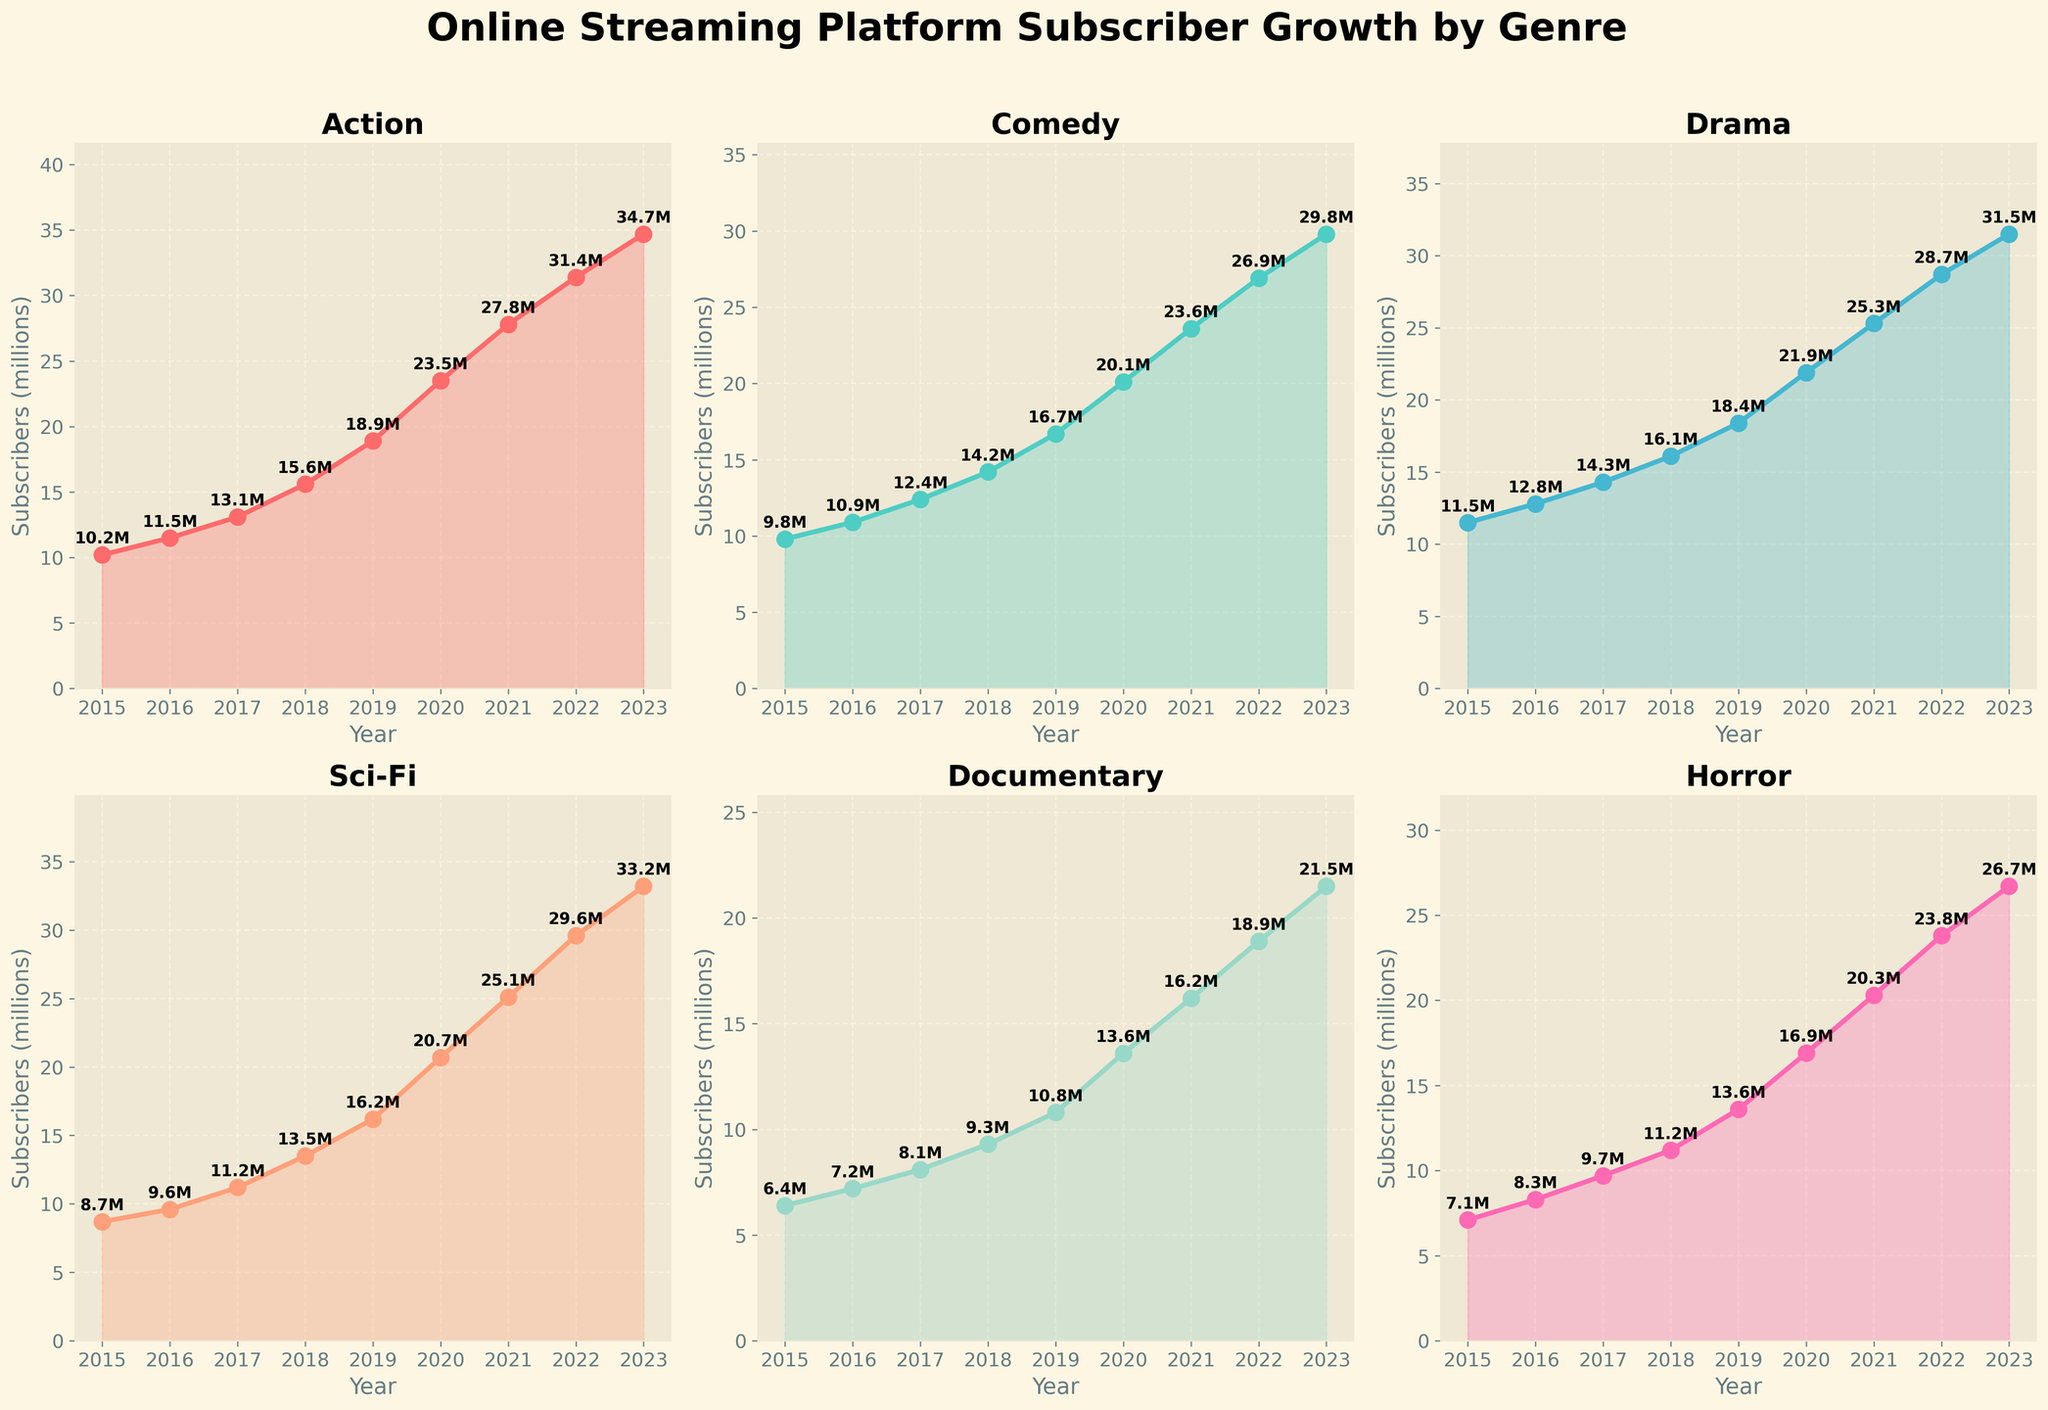Which genre had the highest subscriber growth in 2023? To determine the genre with the highest subscriber growth in 2023, look for the subplot with the highest value on the y-axis for the year 2023. The values are indicated by both the line height and data point annotations. Action genre shows the highest value at 34.7M.
Answer: Action From 2015 to 2023, which genre had the most consistent growth rate? Consistent growth rate can be identified by looking for the subplot with the most evenly spaced data points and a smooth linear increase. All lines should not show dramatic spikes or drops. Drama shows a consistent and smooth increase from 11.5M in 2015 to 31.5M in 2023.
Answer: Drama What was the difference in subscriber count for Comedy genre between 2017 and 2022? To find the difference, subtract the number of subscribers in 2017 from those in 2022 for the Comedy genre: 26.9M (2022) - 12.4M (2017) = 14.5M
Answer: 14.5M Which genre had the smallest growth in subscribers between 2016 and 2019, and by how much did it grow? To find the smallest growth, calculate the difference in subscribers for each genre between 2016 and 2019, and identify the smallest value. For Documentary: 10.8M - 7.2M = 3.6M
Answer: Documentary, 3.6M How does the subscriber count for Horror in 2020 compare to Sci-Fi in 2018? Compare the values of both: Horror in 2020 is 16.9M and Sci-Fi in 2018 is 13.5M. Horror in 2020 is greater by 16.9M - 13.5M = 3.4M
Answer: Horror in 2020 is higher by 3.4M What is the average subscriber count for Sci-Fi genre from 2019 to 2023? Calculate the average by summing the Sci-Fi subscriber counts from 2019 to 2023 and dividing by the number of years: (16.2M + 20.7M + 25.1M + 29.6M + 33.2M) / 5 = 124.8M / 5 = 24.96M
Answer: 24.96M Which genre saw the largest relative increase in subscribers from 2015 to 2023? To find the largest relative increase, compute the percentage change for each genre and compare them: Action (34.7/10.2 - 1) * 100 = 240%, Sci-Fi (33.2/8.7 - 1) * 100 = 281%, others are lower. Sci-Fi has the highest percentage increase at 281%.
Answer: Sci-Fi At any year during the period 2015-2023, did Documentary ever surpass Comedy in subscriber count? By observing the plotted subplots, compare the y-axis values for Documentary and Comedy for each year from 2015 to 2023. Documentary never surpasses Comedy in any year throughout the given period.
Answer: No What was the total subscriber count for all genres combined in 2021? Calculate the total by summing the subscribers across all genres for 2021: 27.8M (Action) + 23.6M (Comedy) + 25.3M (Drama) + 25.1M (Sci-Fi) + 16.2M (Documentary) + 20.3M (Horror) = 138.3M
Answer: 138.3M 